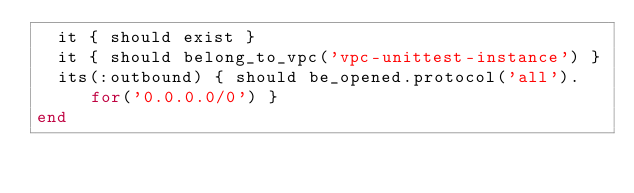<code> <loc_0><loc_0><loc_500><loc_500><_Ruby_>  it { should exist }
  it { should belong_to_vpc('vpc-unittest-instance') }
  its(:outbound) { should be_opened.protocol('all').for('0.0.0.0/0') }
end

</code> 